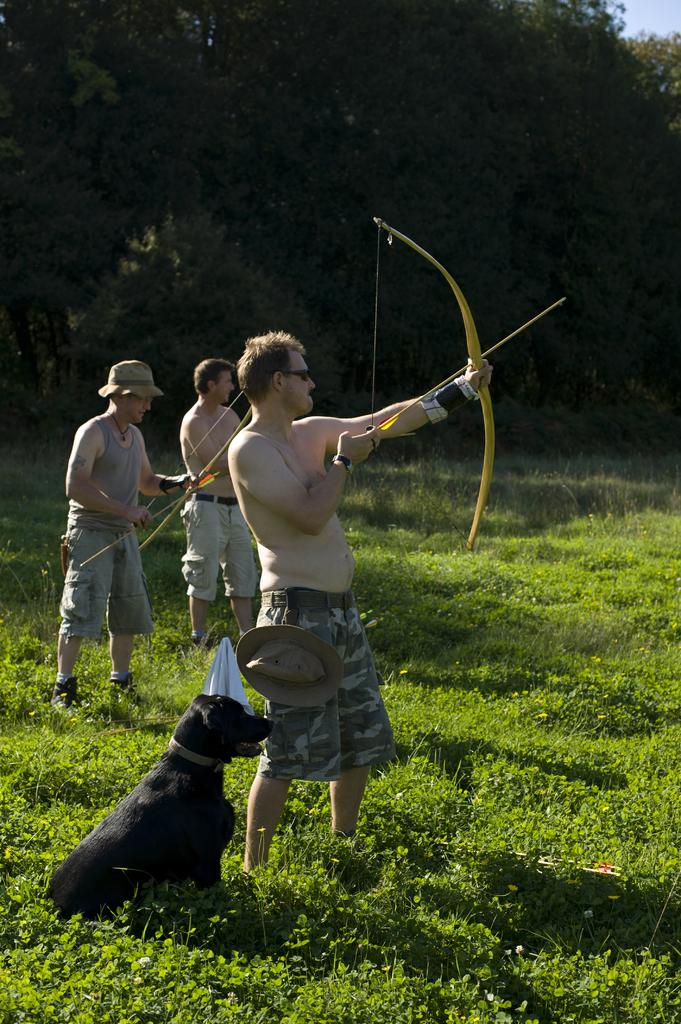What are the persons in the center of the image holding? The persons in the center of the image are holding a bow and arrow. What animal can be seen at the bottom of the image? There is a dog at the bottom of the image. What type of vegetation is present at the bottom of the image? Grass is present at the bottom of the image. What can be seen in the background of the image? Trees, grass, and the sky are visible in the background of the image. What type of feather can be seen in the image? There is no feather present in the image. What fictional characters are interacting with the dog in the image? The image does not depict any fictional characters; it features persons holding a bow and arrow, a dog, and natural elements like grass and trees. 